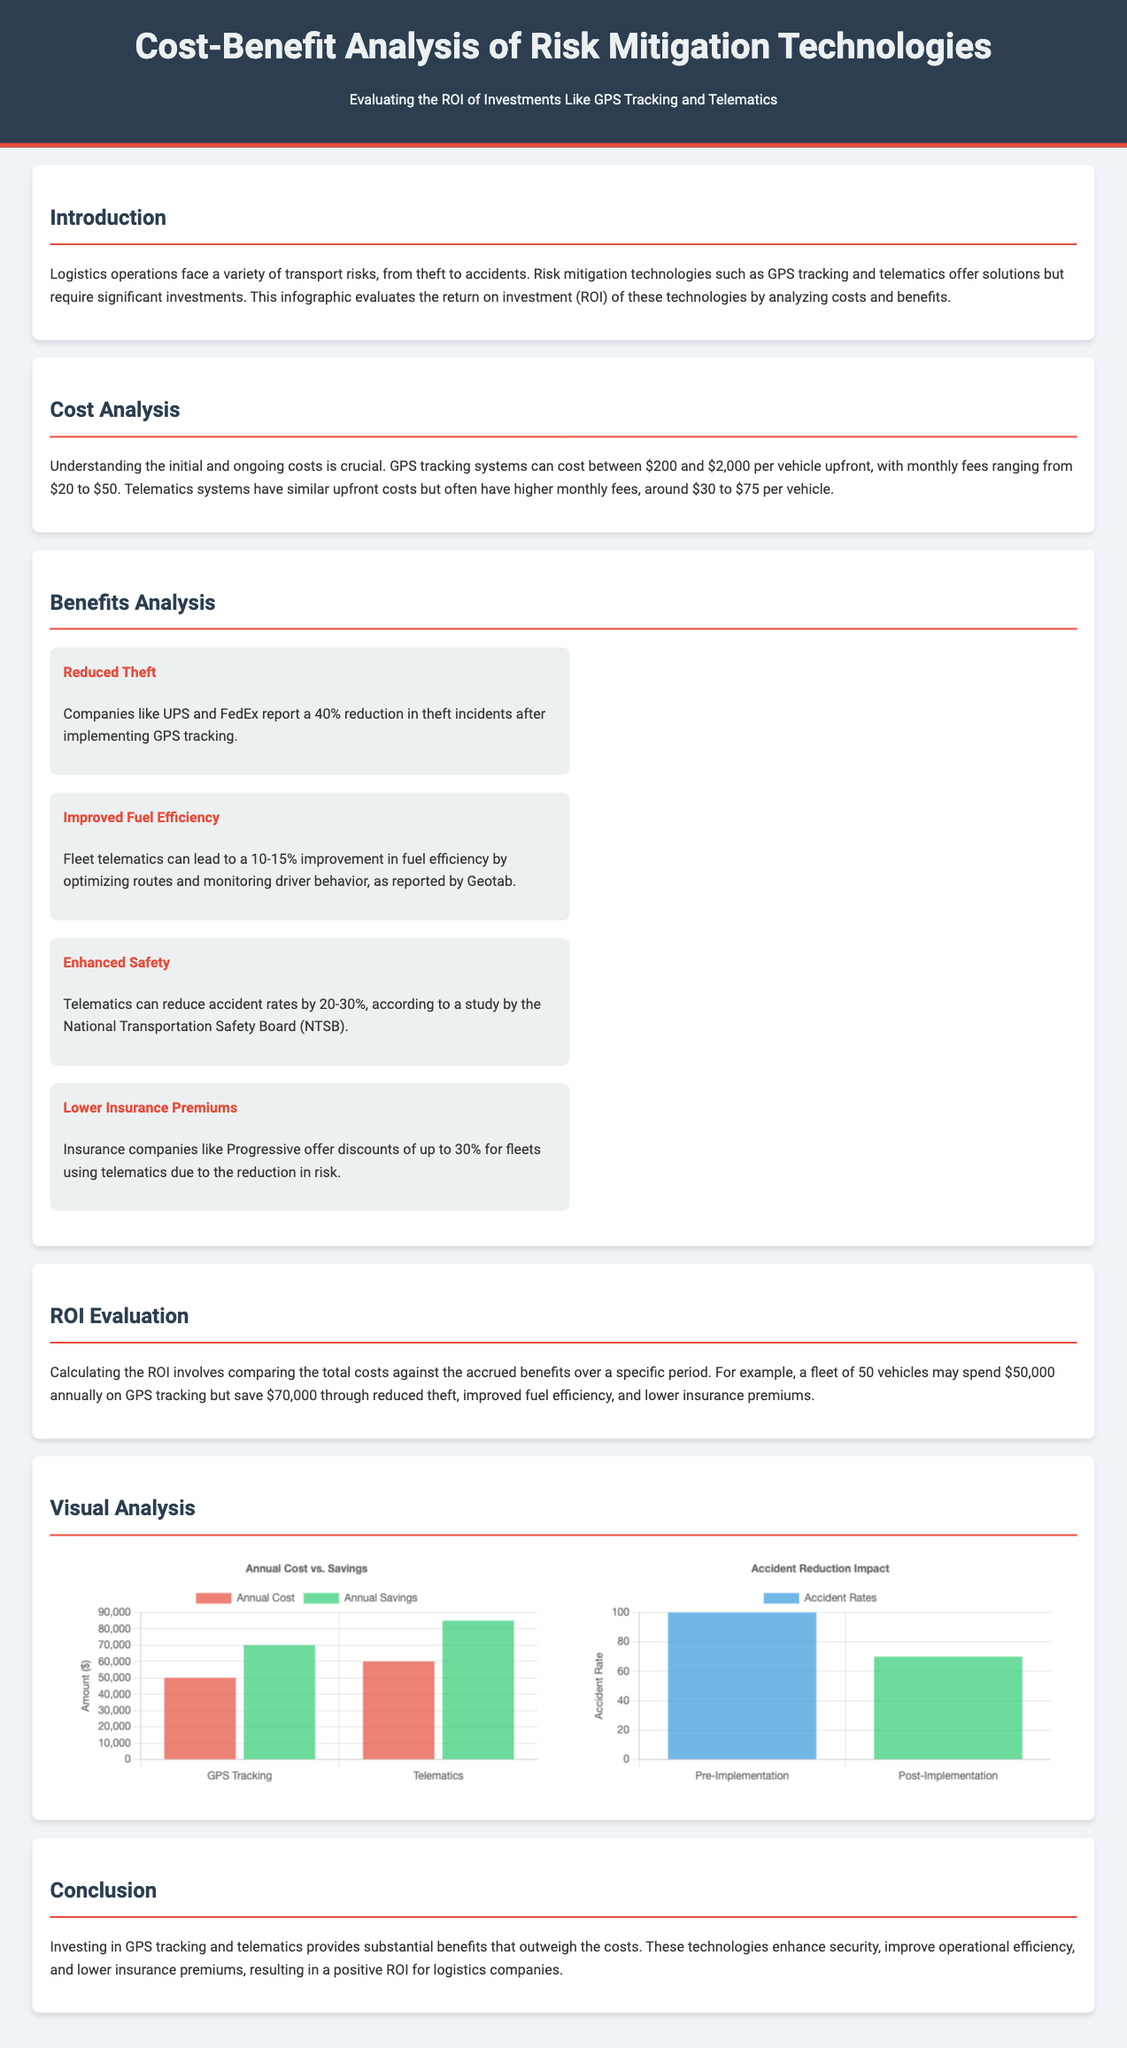What is the upfront cost range for GPS tracking systems? The upfront cost for GPS tracking systems can range from $200 to $2,000 per vehicle.
Answer: $200 to $2,000 What percentage reduction in theft incidents do companies report after implementing GPS tracking? Companies like UPS and FedEx report a 40% reduction in theft incidents.
Answer: 40% What are the estimated savings from reduced theft, improved fuel efficiency, and lower insurance premiums for a fleet of 50 vehicles using GPS tracking? A fleet may save $70,000 through reduced theft, improved fuel efficiency, and lower insurance premiums.
Answer: $70,000 What is the accident rate reduction percentage according to the National Transportation Safety Board? Telematics can reduce accident rates by 20-30%, according to the NTSB.
Answer: 20-30% What is the annual cost for telematics systems compared to GPS tracking systems? The annual cost of telematics can be around $60,000 while GPS tracking is about $50,000.
Answer: $60,000 What does the first bar chart in the document illustrate? The first bar chart illustrates the comparison of annual costs and savings for GPS tracking and telematics.
Answer: Annual Cost vs. Savings What is the impact of telematics on fuel efficiency improvement? Fleet telematics can lead to a 10-15% improvement in fuel efficiency.
Answer: 10-15% What kind of discount do insurance companies offer for using telematics? Insurance companies offer discounts of up to 30% for fleets using telematics.
Answer: Up to 30% What is the primary conclusion regarding the investment in GPS tracking and telematics? Investing in GPS tracking and telematics provides substantial benefits that outweigh the costs, resulting in a positive ROI.
Answer: Positive ROI 